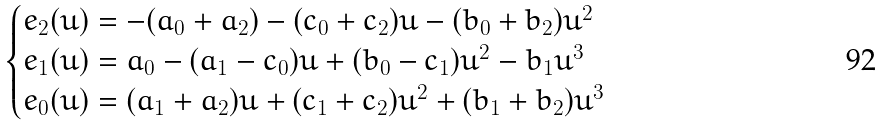Convert formula to latex. <formula><loc_0><loc_0><loc_500><loc_500>\begin{cases} e _ { 2 } ( u ) = - ( a _ { 0 } + a _ { 2 } ) - ( c _ { 0 } + c _ { 2 } ) u - ( b _ { 0 } + b _ { 2 } ) u ^ { 2 } \\ e _ { 1 } ( u ) = a _ { 0 } - ( a _ { 1 } - c _ { 0 } ) u + ( b _ { 0 } - c _ { 1 } ) u ^ { 2 } - b _ { 1 } u ^ { 3 } \\ e _ { 0 } ( u ) = ( a _ { 1 } + a _ { 2 } ) u + ( c _ { 1 } + c _ { 2 } ) u ^ { 2 } + ( b _ { 1 } + b _ { 2 } ) u ^ { 3 } \end{cases}</formula> 